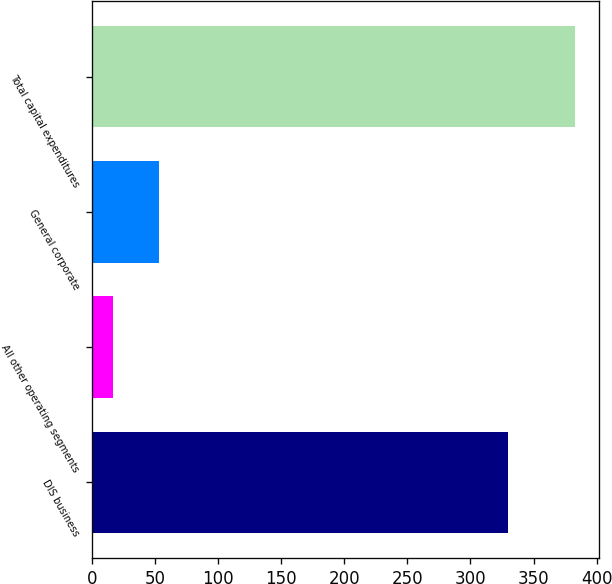Convert chart. <chart><loc_0><loc_0><loc_500><loc_500><bar_chart><fcel>DIS business<fcel>All other operating segments<fcel>General corporate<fcel>Total capital expenditures<nl><fcel>330<fcel>16<fcel>52.7<fcel>383<nl></chart> 